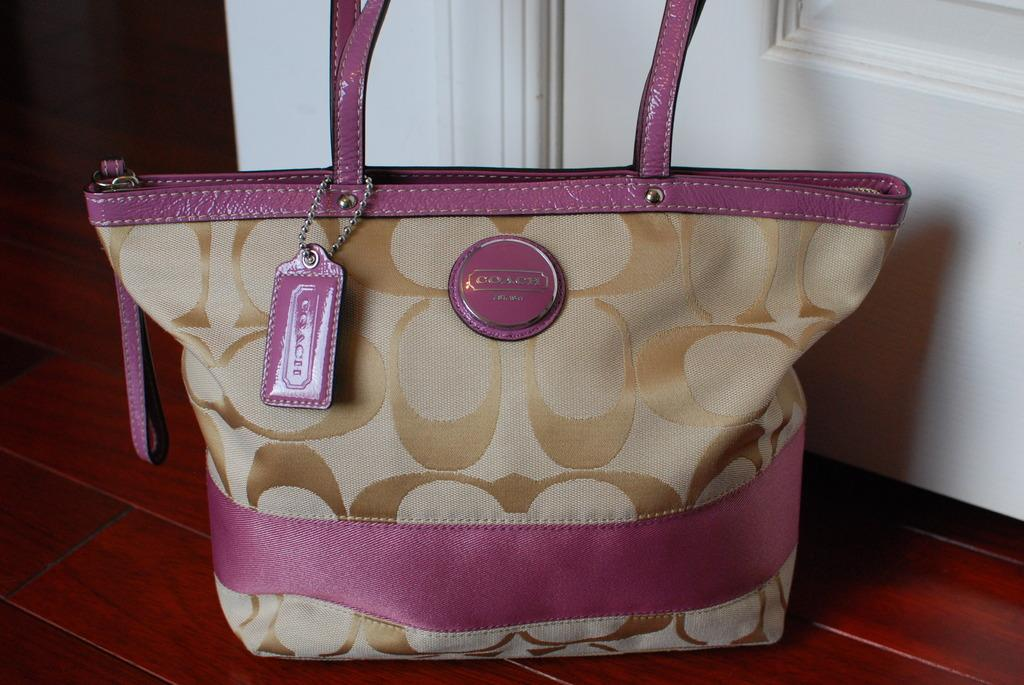What object can be seen in the image? There is a bag in the image. What colors are used for the bag? The bag is pink and biscuit colored. Where is the bag located in the image? The bag is placed on the floor. What can be seen in the background of the image? There is a door in the background of the image. What type of button is attached to the part of the bag in the image? There is no button present on the bag in the image. 